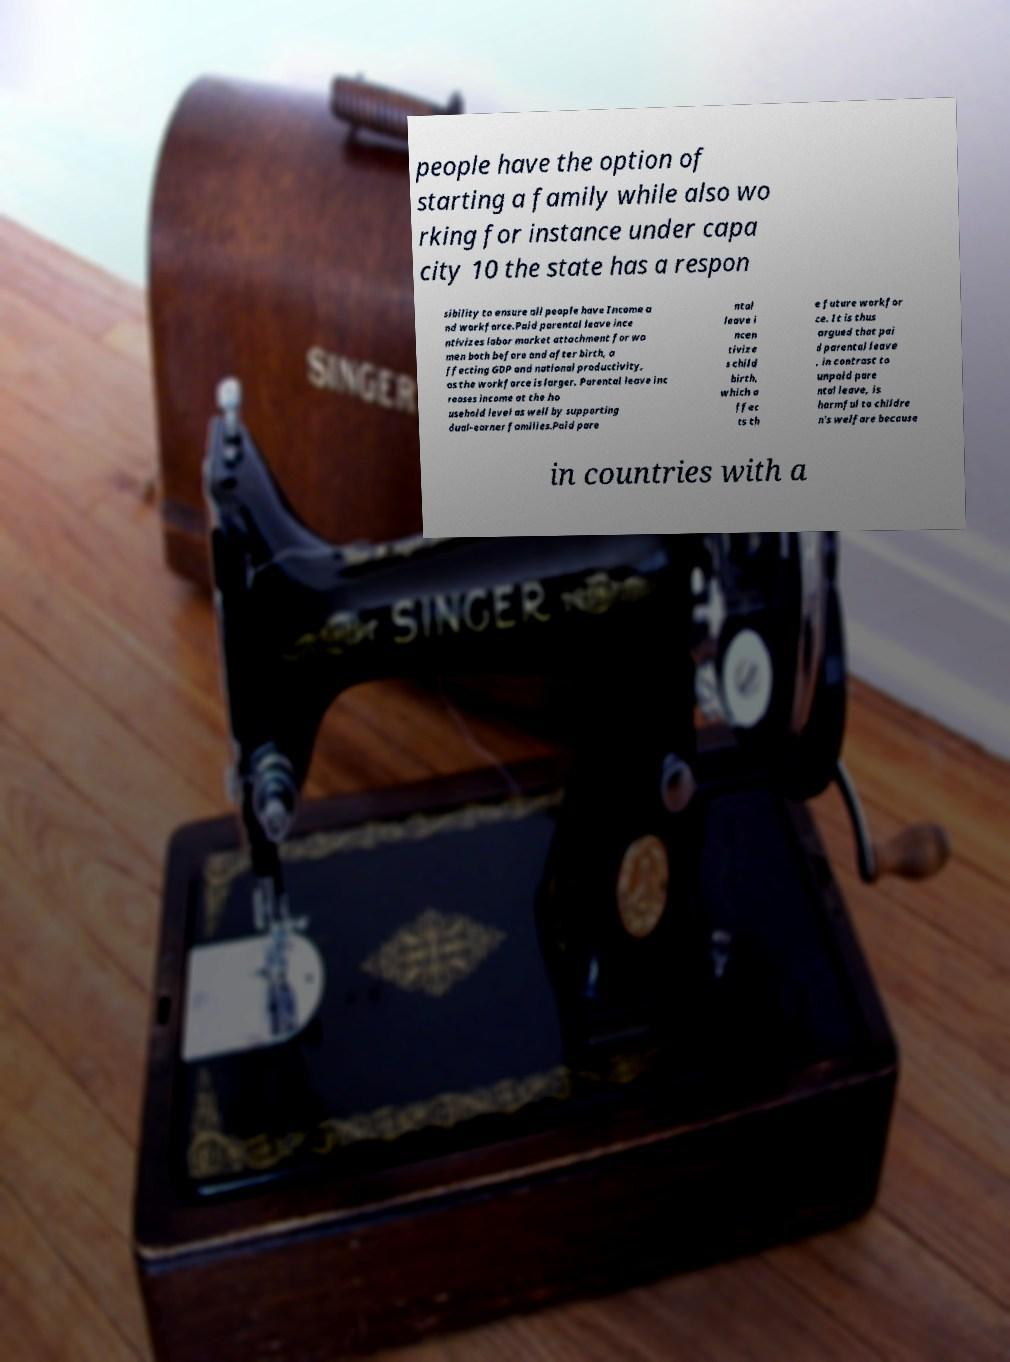There's text embedded in this image that I need extracted. Can you transcribe it verbatim? people have the option of starting a family while also wo rking for instance under capa city 10 the state has a respon sibility to ensure all people have Income a nd workforce.Paid parental leave ince ntivizes labor market attachment for wo men both before and after birth, a ffecting GDP and national productivity, as the workforce is larger. Parental leave inc reases income at the ho usehold level as well by supporting dual-earner families.Paid pare ntal leave i ncen tivize s child birth, which a ffec ts th e future workfor ce. It is thus argued that pai d parental leave , in contrast to unpaid pare ntal leave, is harmful to childre n's welfare because in countries with a 